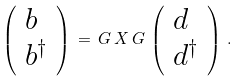<formula> <loc_0><loc_0><loc_500><loc_500>\left ( \begin{array} { l } b \\ b ^ { \dag } \end{array} \right ) \, = \, G \, X \, G \, \left ( \begin{array} { l } d \\ d ^ { \dag } \end{array} \right ) \, .</formula> 